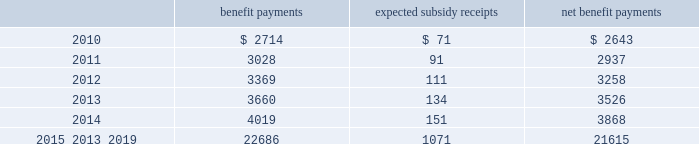Mastercard incorporated notes to consolidated financial statements 2014 ( continued ) ( in thousands , except percent and per share data ) the company does not make any contributions to its postretirement plan other than funding benefits payments .
The table summarizes expected net benefit payments from the company 2019s general assets through 2019 : benefit payments expected subsidy receipts benefit payments .
The company provides limited postemployment benefits to eligible former u.s .
Employees , primarily severance under a formal severance plan ( the 201cseverance plan 201d ) .
The company accounts for severance expense by accruing the expected cost of the severance benefits expected to be provided to former employees after employment over their relevant service periods .
The company updates the assumptions in determining the severance accrual by evaluating the actual severance activity and long-term trends underlying the assumptions .
As a result of updating the assumptions , the company recorded incremental severance expense ( benefit ) related to the severance plan of $ 3471 , $ 2643 and $ ( 3418 ) , respectively , during the years 2009 , 2008 and 2007 .
These amounts were part of total severance expenses of $ 135113 , $ 32997 and $ 21284 in 2009 , 2008 and 2007 , respectively , included in general and administrative expenses in the accompanying consolidated statements of operations .
Note 14 .
Debt on april 28 , 2008 , the company extended its committed unsecured revolving credit facility , dated as of april 28 , 2006 ( the 201ccredit facility 201d ) , for an additional year .
The new expiration date of the credit facility is april 26 , 2011 .
The available funding under the credit facility will remain at $ 2500000 through april 27 , 2010 and then decrease to $ 2000000 during the final year of the credit facility agreement .
Other terms and conditions in the credit facility remain unchanged .
The company 2019s option to request that each lender under the credit facility extend its commitment was provided pursuant to the original terms of the credit facility agreement .
Borrowings under the facility are available to provide liquidity in the event of one or more settlement failures by mastercard international customers and , subject to a limit of $ 500000 , for general corporate purposes .
The facility fee and borrowing cost are contingent upon the company 2019s credit rating .
At december 31 , 2009 , the facility fee was 7 basis points on the total commitment , or approximately $ 1774 annually .
Interest on borrowings under the credit facility would be charged at the london interbank offered rate ( libor ) plus an applicable margin of 28 basis points or an alternative base rate , and a utilization fee of 10 basis points would be charged if outstanding borrowings under the facility exceed 50% ( 50 % ) of commitments .
At the inception of the credit facility , the company also agreed to pay upfront fees of $ 1250 and administrative fees of $ 325 , which are being amortized over five years .
Facility and other fees associated with the credit facility totaled $ 2222 , $ 2353 and $ 2477 for each of the years ended december 31 , 2009 , 2008 and 2007 , respectively .
Mastercard was in compliance with the covenants of the credit facility and had no borrowings under the credit facility at december 31 , 2009 or december 31 , 2008 .
The majority of credit facility lenders are members or affiliates of members of mastercard international .
In june 1998 , mastercard international issued ten-year unsecured , subordinated notes ( the 201cnotes 201d ) paying a fixed interest rate of 6.67% ( 6.67 % ) per annum .
Mastercard repaid the entire principal amount of $ 80000 on june 30 , 2008 pursuant to the terms of the notes .
The interest expense on the notes was $ 2668 and $ 5336 for each of the years ended december 31 , 2008 and 2007 , respectively. .
What was the ratio of the expected net benefit payments of 2011 to 2012? 
Rationale: the ratio of the expected net benefit payments of 2011 to 2012 was 0.9 to 1
Computations: (2937 / 3258)
Answer: 0.90147. 